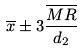<formula> <loc_0><loc_0><loc_500><loc_500>\overline { x } \pm 3 \frac { \overline { M R } } { d _ { 2 } }</formula> 